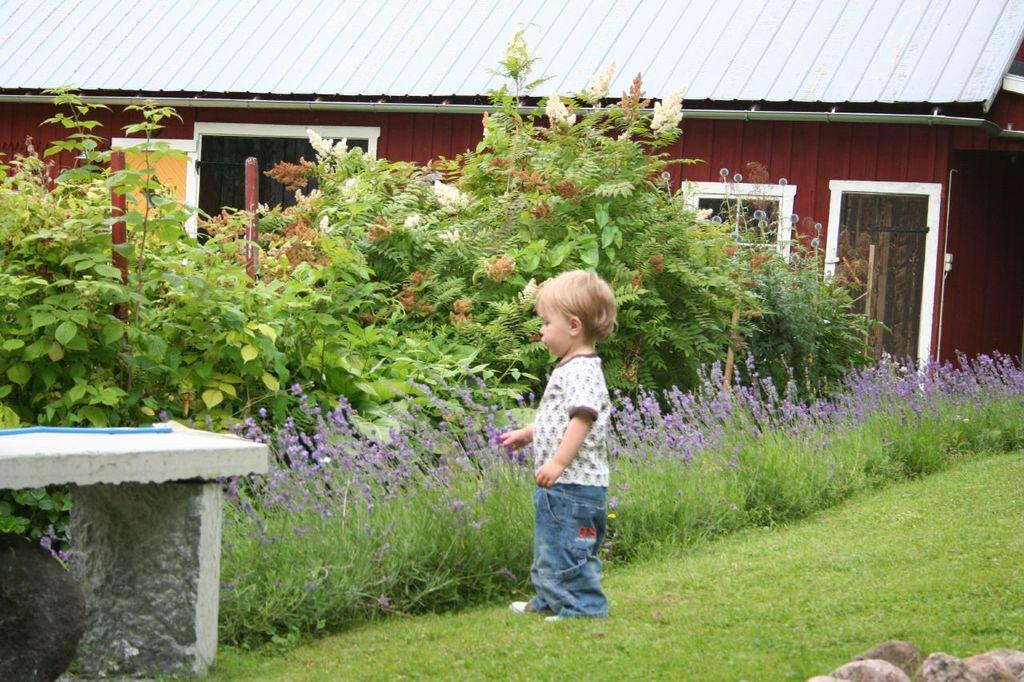What is the main subject of the image? There is a boy standing on the ground in the image. What type of objects can be seen on the ground? There are stones visible in the image. What type of furniture is present in the image? There is a bench in the image. What type of vegetation is present in the image? Plants and flowers are visible in the image. What type of structures are present in the image? There are poles and a house visible in the image. What can be seen in the background of the image? There is a house and a roof visible in the background of the image. What type of bun is the boy holding in the image? There is no bun present in the image. What type of fuel is being used by the house in the background? The image does not provide information about the type of fuel used by the house in the background. 